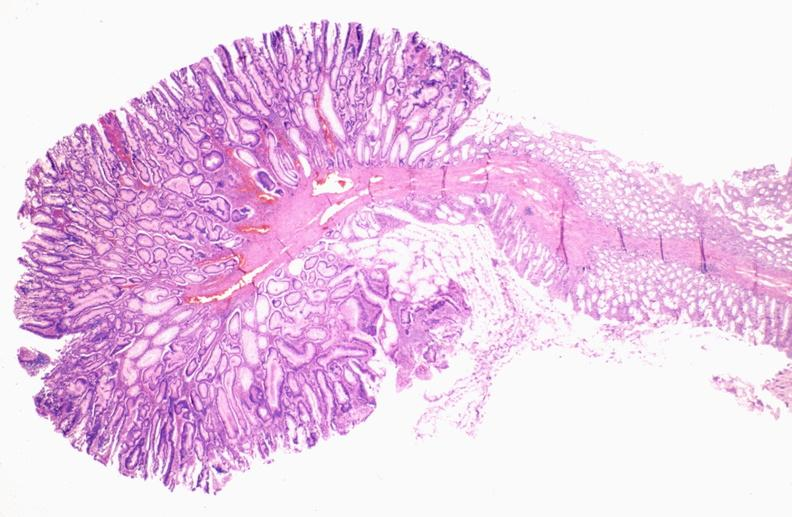does rocky mountain show colon, adenomatous polyp?
Answer the question using a single word or phrase. No 